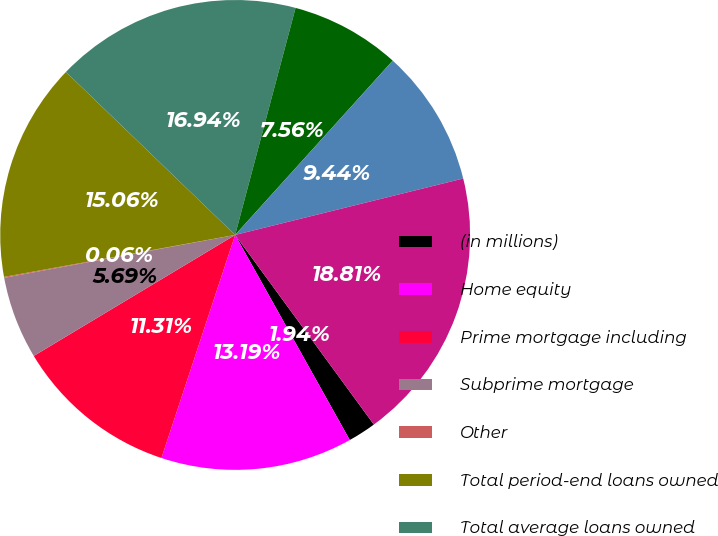Convert chart to OTSL. <chart><loc_0><loc_0><loc_500><loc_500><pie_chart><fcel>(in millions)<fcel>Home equity<fcel>Prime mortgage including<fcel>Subprime mortgage<fcel>Other<fcel>Total period-end loans owned<fcel>Total average loans owned<fcel>Prime mortgage<fcel>Option ARMs<fcel>Average assets<nl><fcel>1.94%<fcel>13.19%<fcel>11.31%<fcel>5.69%<fcel>0.06%<fcel>15.06%<fcel>16.94%<fcel>7.56%<fcel>9.44%<fcel>18.81%<nl></chart> 